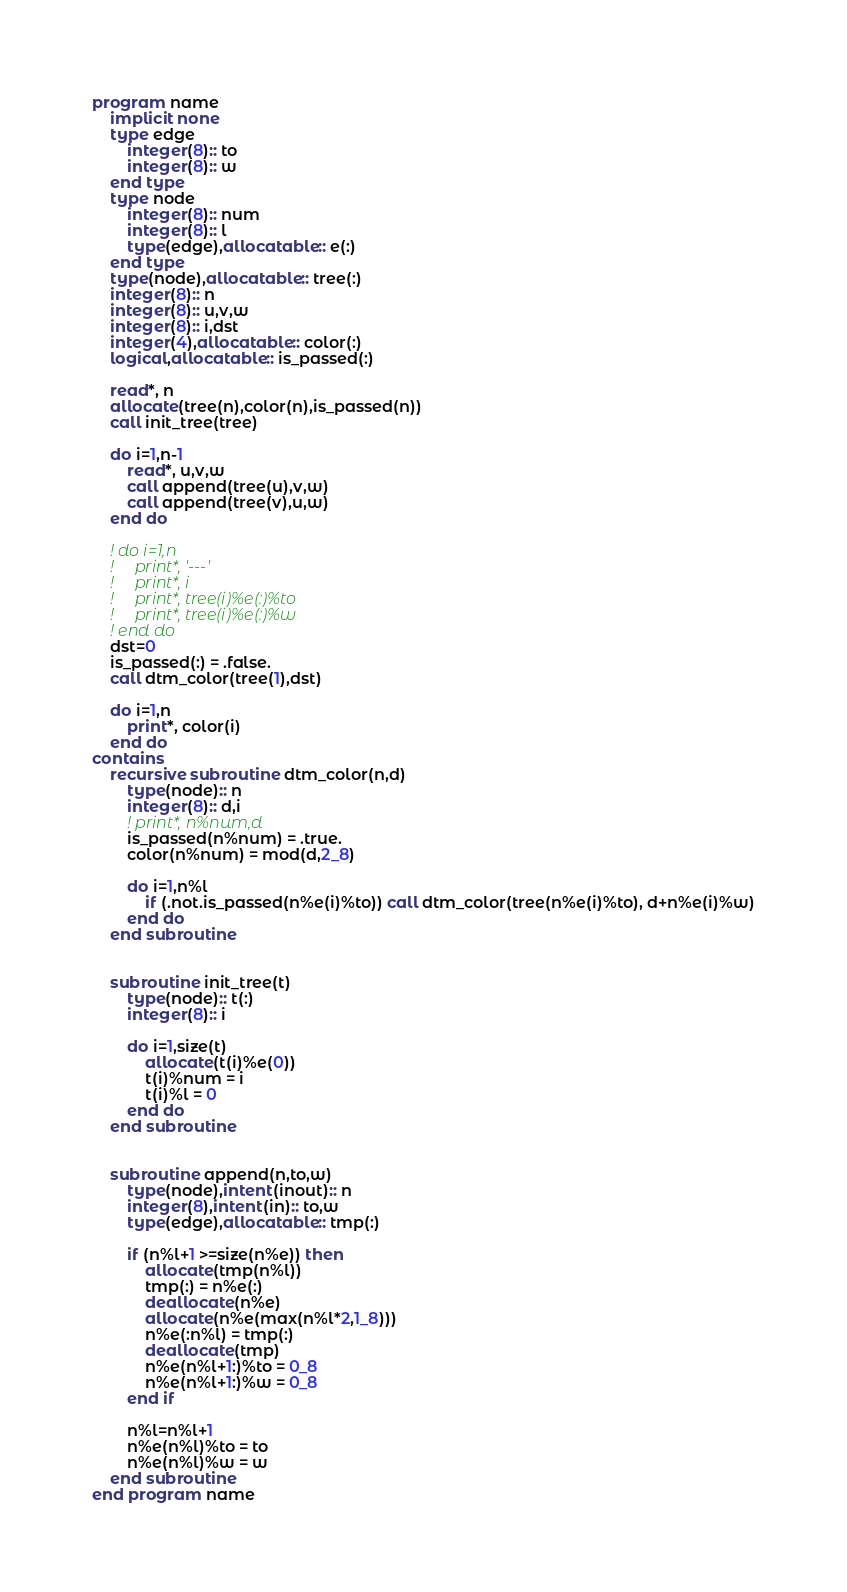<code> <loc_0><loc_0><loc_500><loc_500><_FORTRAN_>program name
    implicit none
    type edge
        integer(8):: to
        integer(8):: w
    end type
    type node
        integer(8):: num
        integer(8):: l
        type(edge),allocatable:: e(:)
    end type
    type(node),allocatable:: tree(:)
    integer(8):: n
    integer(8):: u,v,w
    integer(8):: i,dst
    integer(4),allocatable:: color(:)
    logical,allocatable:: is_passed(:)

    read*, n
    allocate(tree(n),color(n),is_passed(n))
    call init_tree(tree)

    do i=1,n-1
        read*, u,v,w
        call append(tree(u),v,w)
        call append(tree(v),u,w)
    end do

    ! do i=1,n
    !     print*, '---'
    !     print*, i
    !     print*, tree(i)%e(:)%to
    !     print*, tree(i)%e(:)%w
    ! end do
    dst=0
    is_passed(:) = .false.
    call dtm_color(tree(1),dst)

    do i=1,n
        print*, color(i)
    end do
contains
    recursive subroutine dtm_color(n,d)
        type(node):: n
        integer(8):: d,i
        ! print*, n%num,d
        is_passed(n%num) = .true.
        color(n%num) = mod(d,2_8)
        
        do i=1,n%l
            if (.not.is_passed(n%e(i)%to)) call dtm_color(tree(n%e(i)%to), d+n%e(i)%w)
        end do
    end subroutine


    subroutine init_tree(t)
        type(node):: t(:)
        integer(8):: i

        do i=1,size(t)
            allocate(t(i)%e(0))
            t(i)%num = i
            t(i)%l = 0
        end do
    end subroutine


    subroutine append(n,to,w)
        type(node),intent(inout):: n
        integer(8),intent(in):: to,w
        type(edge),allocatable:: tmp(:)

        if (n%l+1 >=size(n%e)) then
            allocate(tmp(n%l))
            tmp(:) = n%e(:)
            deallocate(n%e)
            allocate(n%e(max(n%l*2,1_8)))
            n%e(:n%l) = tmp(:)
            deallocate(tmp)
            n%e(n%l+1:)%to = 0_8
            n%e(n%l+1:)%w = 0_8
        end if

        n%l=n%l+1
        n%e(n%l)%to = to
        n%e(n%l)%w = w
    end subroutine
end program name</code> 